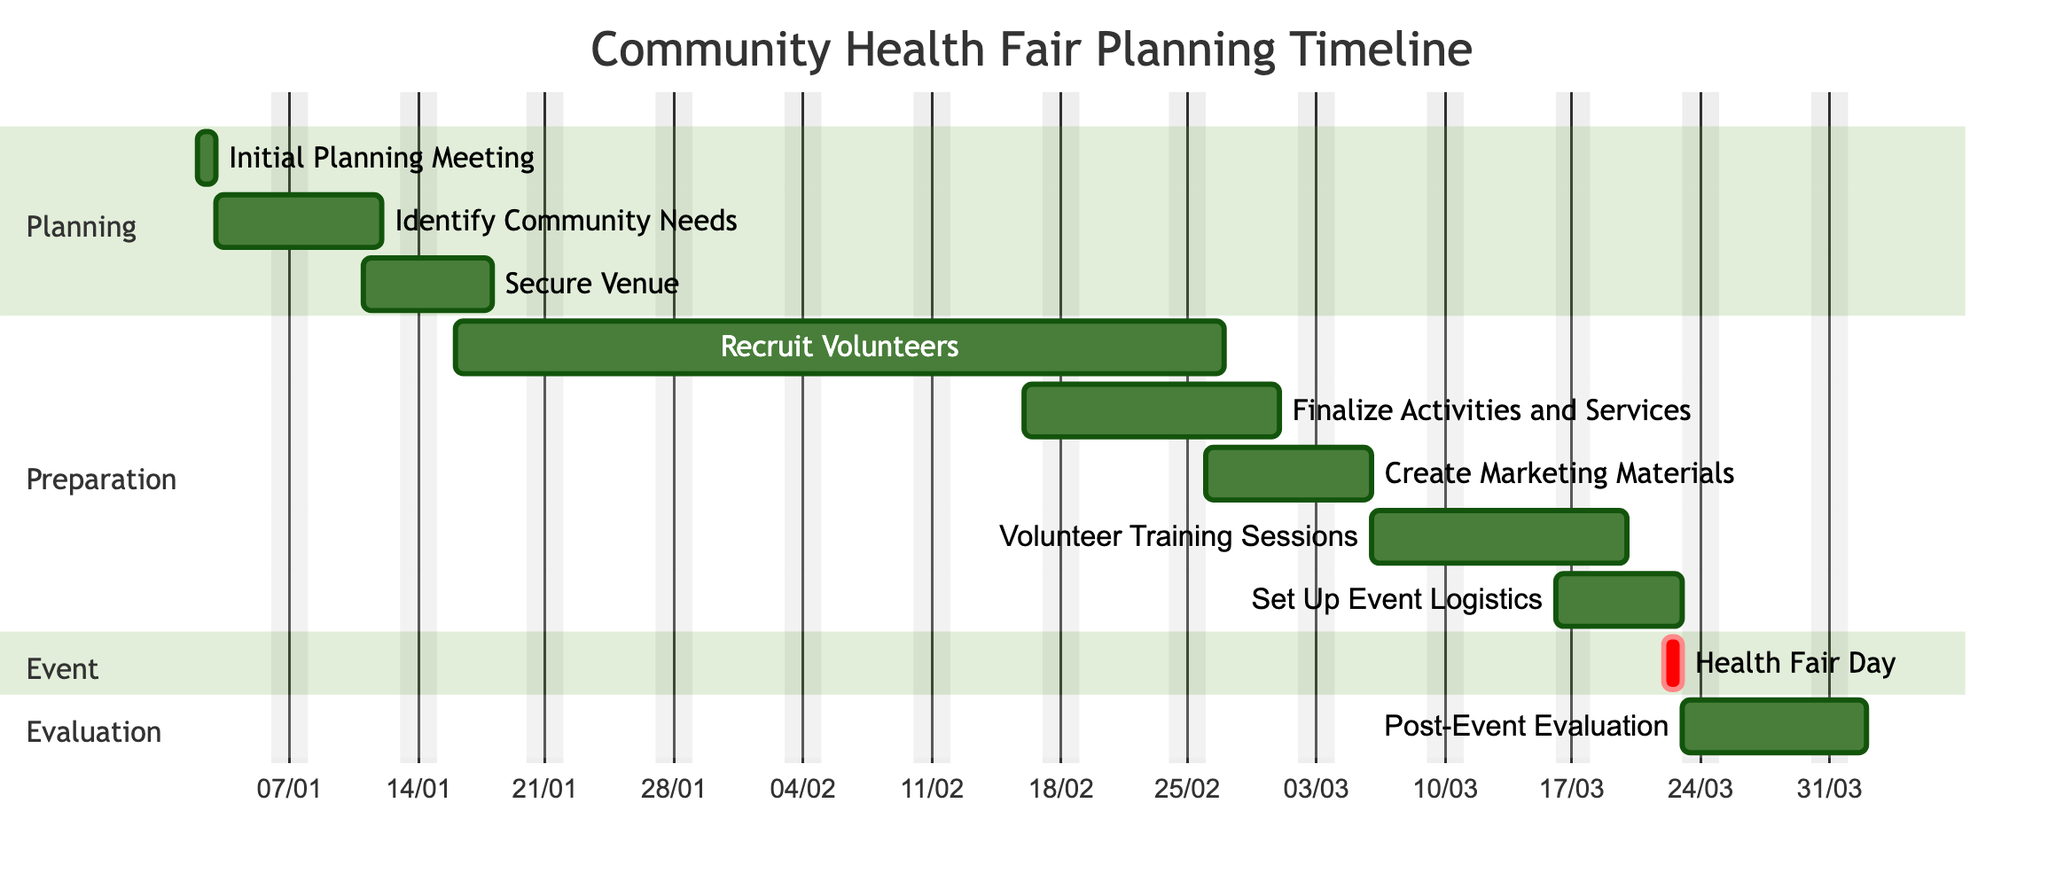What is the duration of the "Identify Community Needs" task? The "Identify Community Needs" task has a duration of 7 days as indicated in the timeline details.
Answer: 7 days Who is responsible for the "Secure Venue" task? According to the chart, the "Secure Venue" task is the responsibility of the Event Coordinator, as outlined next to the task’s details.
Answer: Event Coordinator How many days are allocated for "Volunteer Training Sessions"? The allocated duration for "Volunteer Training Sessions" is 10 days, as specified in the timeline.
Answer: 10 days What is the end date of "Create Marketing Materials"? The end date for the "Create Marketing Materials" task is March 5, 2024, which can be found in the timeline section detailing its duration.
Answer: 2024-03-05 Which two tasks are back-to-back in the timeline? The task "Volunteer Training Sessions" ends on March 15, 2024, and the task "Set Up Event Logistics" starts on the next day, March 16, 2024. This indicates that they are back-to-back.
Answer: Volunteer Training Sessions and Set Up Event Logistics What activities occur during the "Planning" phase? The activities that fall under the "Planning" phase include "Initial Planning Meeting," "Identify Community Needs," and "Secure Venue," as listed in the sections of the Gantt Chart.
Answer: Initial Planning Meeting, Identify Community Needs, Secure Venue When is the "Health Fair Day" scheduled? The "Health Fair Day" is specifically scheduled for March 22, 2024, as depicted in the timeline of the Gantt Chart.
Answer: March 22, 2024 How long does the entire planning process take from start to finish? The planning process begins on January 2, 2024, with the "Initial Planning Meeting" and concludes with the "Post-Event Evaluation" ending on March 30, 2024. This calculates to a total of 88 days.
Answer: 88 days Which team is tasked with the "Post-Event Evaluation"? The task of conducting the "Post-Event Evaluation" is assigned to the Evaluation Committee, which is noted as responsible in the task details of the timeline.
Answer: Evaluation Committee 